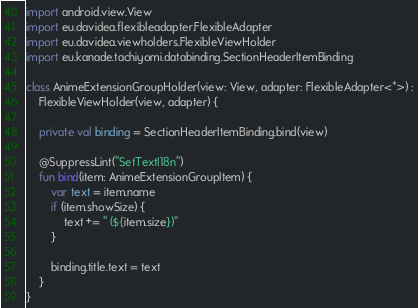<code> <loc_0><loc_0><loc_500><loc_500><_Kotlin_>import android.view.View
import eu.davidea.flexibleadapter.FlexibleAdapter
import eu.davidea.viewholders.FlexibleViewHolder
import eu.kanade.tachiyomi.databinding.SectionHeaderItemBinding

class AnimeExtensionGroupHolder(view: View, adapter: FlexibleAdapter<*>) :
    FlexibleViewHolder(view, adapter) {

    private val binding = SectionHeaderItemBinding.bind(view)

    @SuppressLint("SetTextI18n")
    fun bind(item: AnimeExtensionGroupItem) {
        var text = item.name
        if (item.showSize) {
            text += " (${item.size})"
        }

        binding.title.text = text
    }
}
</code> 